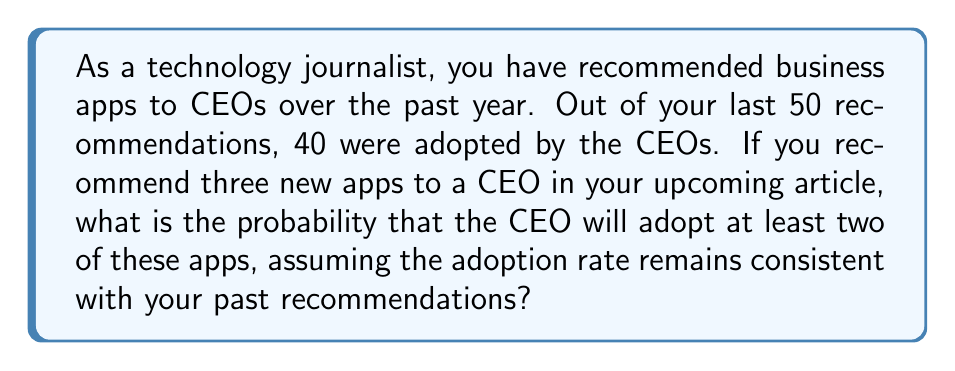Help me with this question. To solve this problem, we need to use the binomial probability distribution. Let's break it down step-by-step:

1. Calculate the probability of a single app being adopted:
   $p = \frac{40}{50} = 0.8$ or 80%

2. The probability of not adopting an app is:
   $q = 1 - p = 0.2$ or 20%

3. We want the probability of adopting at least 2 out of 3 apps. This can happen in two ways:
   a) Adopting exactly 2 apps
   b) Adopting all 3 apps

4. Let's use the binomial probability formula:
   $$P(X = k) = \binom{n}{k} p^k q^{n-k}$$
   where $n$ is the number of trials, $k$ is the number of successes, $p$ is the probability of success, and $q$ is the probability of failure.

5. For exactly 2 adoptions:
   $$P(X = 2) = \binom{3}{2} (0.8)^2 (0.2)^1 = 3 \cdot 0.64 \cdot 0.2 = 0.384$$

6. For all 3 adoptions:
   $$P(X = 3) = \binom{3}{3} (0.8)^3 (0.2)^0 = 1 \cdot 0.512 \cdot 1 = 0.512$$

7. The probability of at least 2 adoptions is the sum of these probabilities:
   $$P(X \geq 2) = P(X = 2) + P(X = 3) = 0.384 + 0.512 = 0.896$$

Therefore, the probability that the CEO will adopt at least two of the three recommended apps is 0.896 or 89.6%.
Answer: 0.896 or 89.6% 